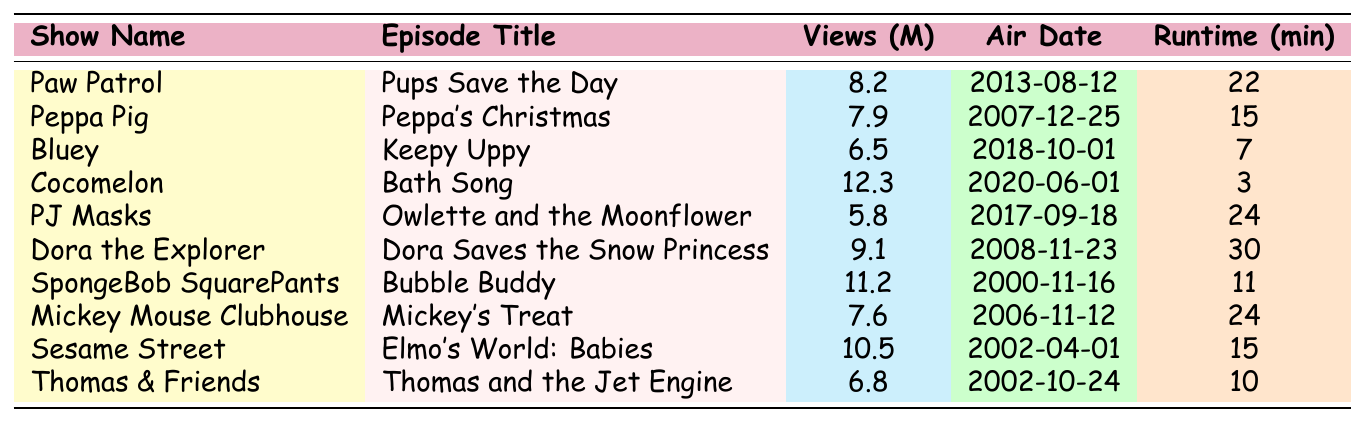What is the episode of Cocomelon called? The table shows that Cocomelon's episode title is "Bath Song."
Answer: Bath Song Which show has the episode titled "Peppa's Christmas"? According to the table, the episode titled "Peppa's Christmas" belongs to the show Peppa Pig.
Answer: Peppa Pig How many views did "Dora Saves the Snow Princess" get? The table indicates that "Dora Saves the Snow Princess" received 9.1 million views.
Answer: 9.1 million Which show has the most views and what is the episode title? The table shows that "Bath Song" from Cocomelon has the most views at 12.3 million.
Answer: Cocomelon, Bath Song What is the average runtime of all the episodes listed? To find the average, add up all runtimes: (22 + 15 + 7 + 3 + 24 + 30 + 11 + 24 + 15 + 10) =  151 minutes. There are 10 episodes, so the average runtime is 151/10 = 15.1 minutes.
Answer: 15.1 minutes Which episode has the highest views after "Bath Song"? The second highest views in the table is from "Bubble Buddy" with 11.2 million views.
Answer: Bubble Buddy Is "Mickey's Treat" longer than 20 minutes? The runtime for "Mickey's Treat" is 24 minutes, which is longer than 20 minutes.
Answer: Yes How many episodes received more than 10 million views? Checking the table, only "Bath Song" received more than 10 million views. So, there is 1 episode with more than 10 million views.
Answer: 1 Which show has the least number of views, and what is the episode title? The table indicates that the episode "Owlette and the Moonflower" from PJ Masks has the least views at 5.8 million.
Answer: PJ Masks, Owlette and the Moonflower What is the difference in views between "Elmo's World: Babies" and "Peppa's Christmas"? "Elmo's World: Babies" has 10.5 million views, and "Peppa's Christmas" has 7.9 million views. The difference is 10.5 - 7.9 = 2.6 million views.
Answer: 2.6 million 